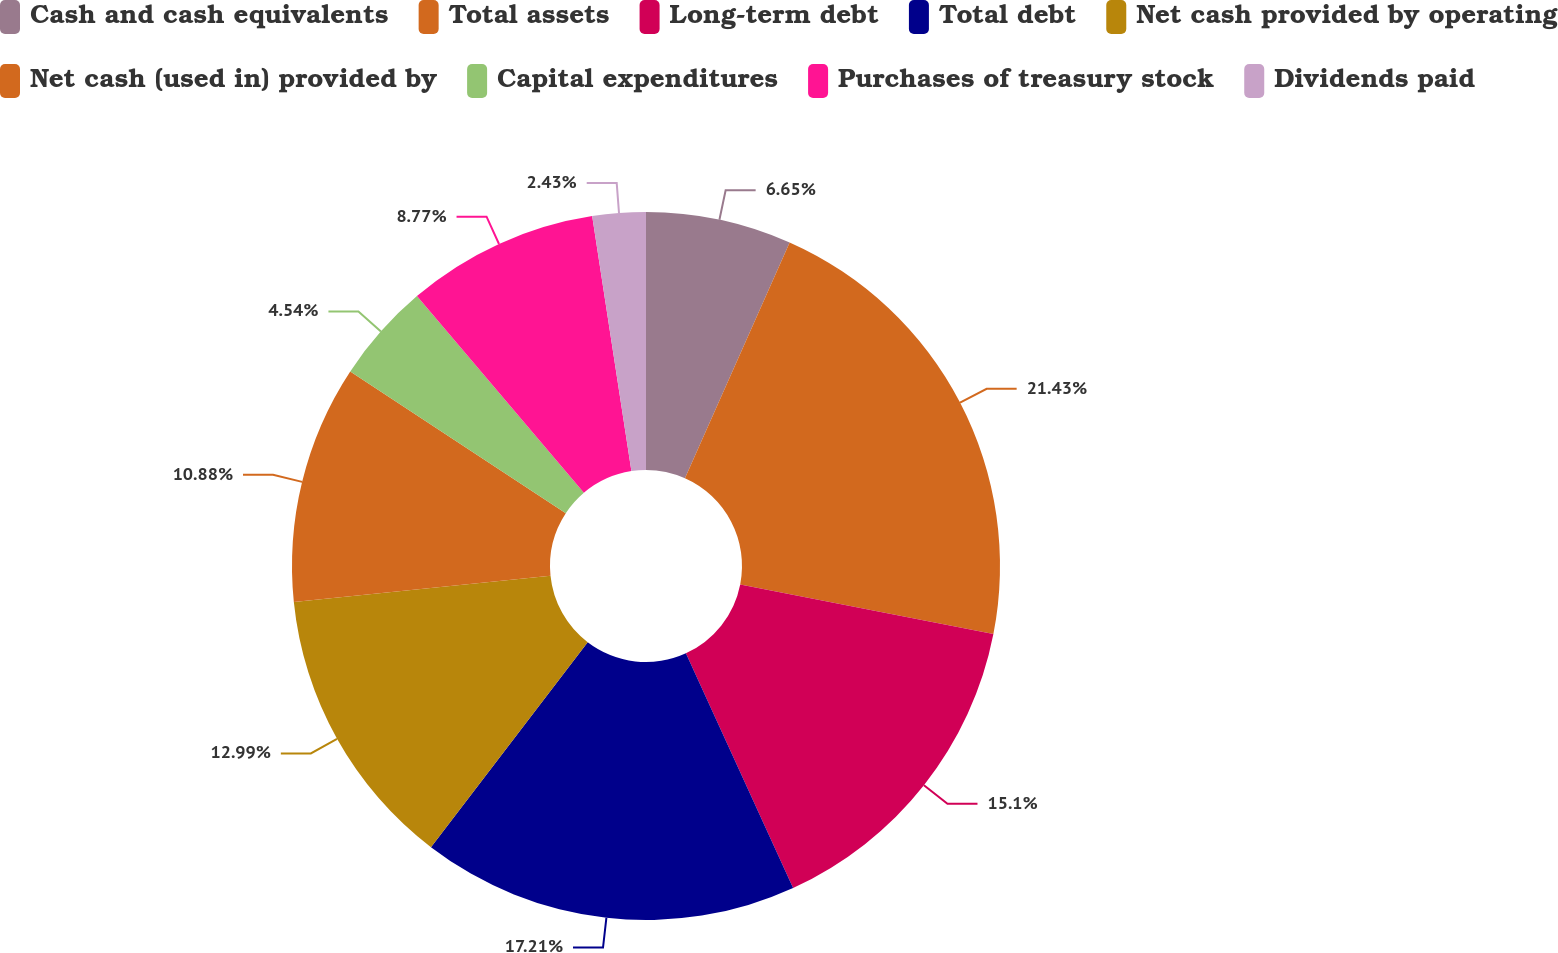Convert chart. <chart><loc_0><loc_0><loc_500><loc_500><pie_chart><fcel>Cash and cash equivalents<fcel>Total assets<fcel>Long-term debt<fcel>Total debt<fcel>Net cash provided by operating<fcel>Net cash (used in) provided by<fcel>Capital expenditures<fcel>Purchases of treasury stock<fcel>Dividends paid<nl><fcel>6.65%<fcel>21.43%<fcel>15.1%<fcel>17.21%<fcel>12.99%<fcel>10.88%<fcel>4.54%<fcel>8.77%<fcel>2.43%<nl></chart> 